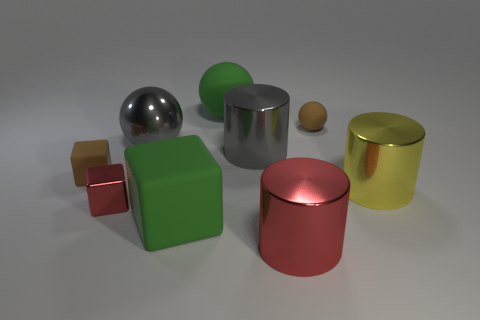Does the brown thing that is behind the small matte cube have the same size as the cylinder on the left side of the large red metal cylinder?
Your answer should be very brief. No. Is the number of big cylinders that are behind the large block greater than the number of big gray metallic things that are behind the metallic sphere?
Ensure brevity in your answer.  Yes. How many other things are the same color as the large rubber ball?
Provide a short and direct response. 1. There is a large metallic ball; is its color the same as the large cylinder behind the small matte cube?
Provide a short and direct response. Yes. There is a brown matte thing that is left of the small red block; how many metal objects are behind it?
Ensure brevity in your answer.  2. What material is the large green thing in front of the small block that is behind the small red metallic block that is in front of the brown ball?
Provide a short and direct response. Rubber. There is a object that is both on the left side of the gray metallic ball and behind the tiny red thing; what is its material?
Your answer should be very brief. Rubber. How many gray objects have the same shape as the large red object?
Provide a succinct answer. 1. What is the size of the brown matte object that is on the right side of the large matte object that is in front of the small rubber block?
Ensure brevity in your answer.  Small. Does the small object in front of the tiny brown block have the same color as the metal cylinder that is in front of the green rubber block?
Provide a short and direct response. Yes. 